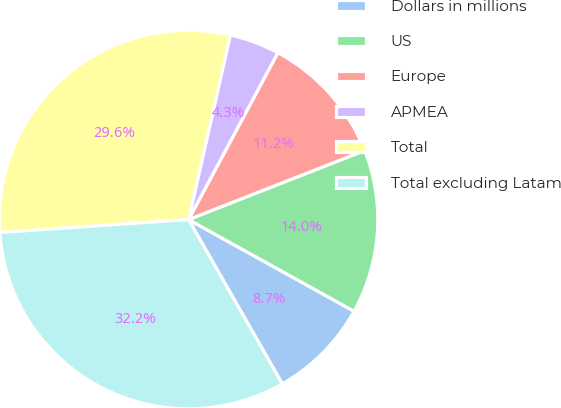Convert chart to OTSL. <chart><loc_0><loc_0><loc_500><loc_500><pie_chart><fcel>Dollars in millions<fcel>US<fcel>Europe<fcel>APMEA<fcel>Total<fcel>Total excluding Latam<nl><fcel>8.7%<fcel>14.0%<fcel>11.23%<fcel>4.28%<fcel>29.63%<fcel>32.16%<nl></chart> 